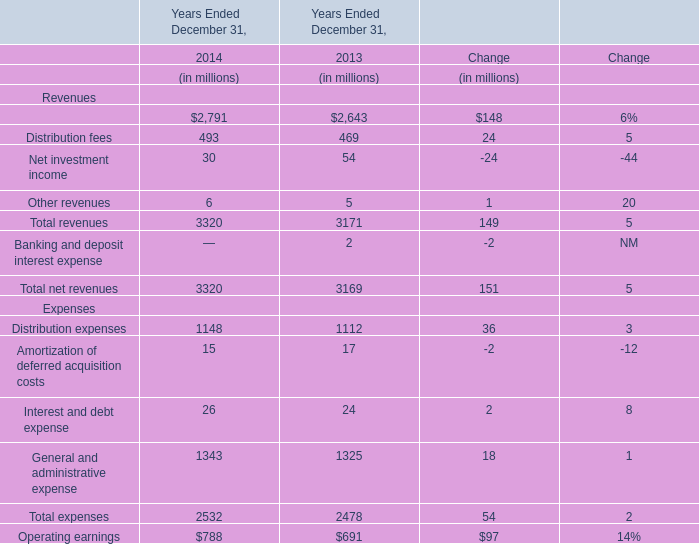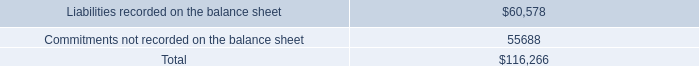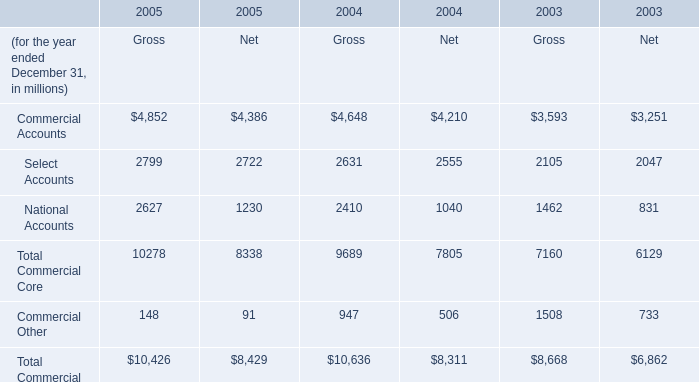What is the total amount of Commitments not recorded on the balance sheet, Select Accounts of 2004 Net, and Commercial Other of 2003 Gross ? 
Computations: ((55688.0 + 2555.0) + 1508.0)
Answer: 59751.0. 